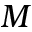<formula> <loc_0><loc_0><loc_500><loc_500>M</formula> 